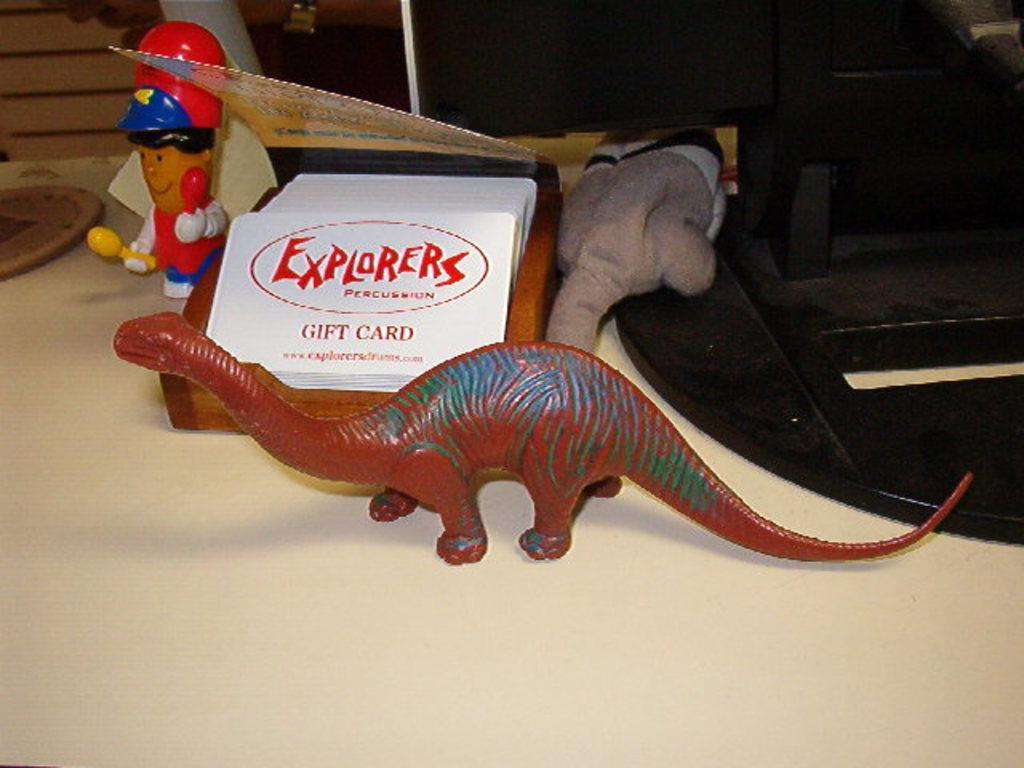What is the main piece of furniture in the image? There is a table in the image. What items can be seen on the table? There are papers and toys on the table. What type of objects are visible in the image? There are systems visible in the image. What type of prose is being written on the papers in the image? There is no indication in the image that any writing is taking place on the papers, so it cannot be determined what type of prose might be present. 